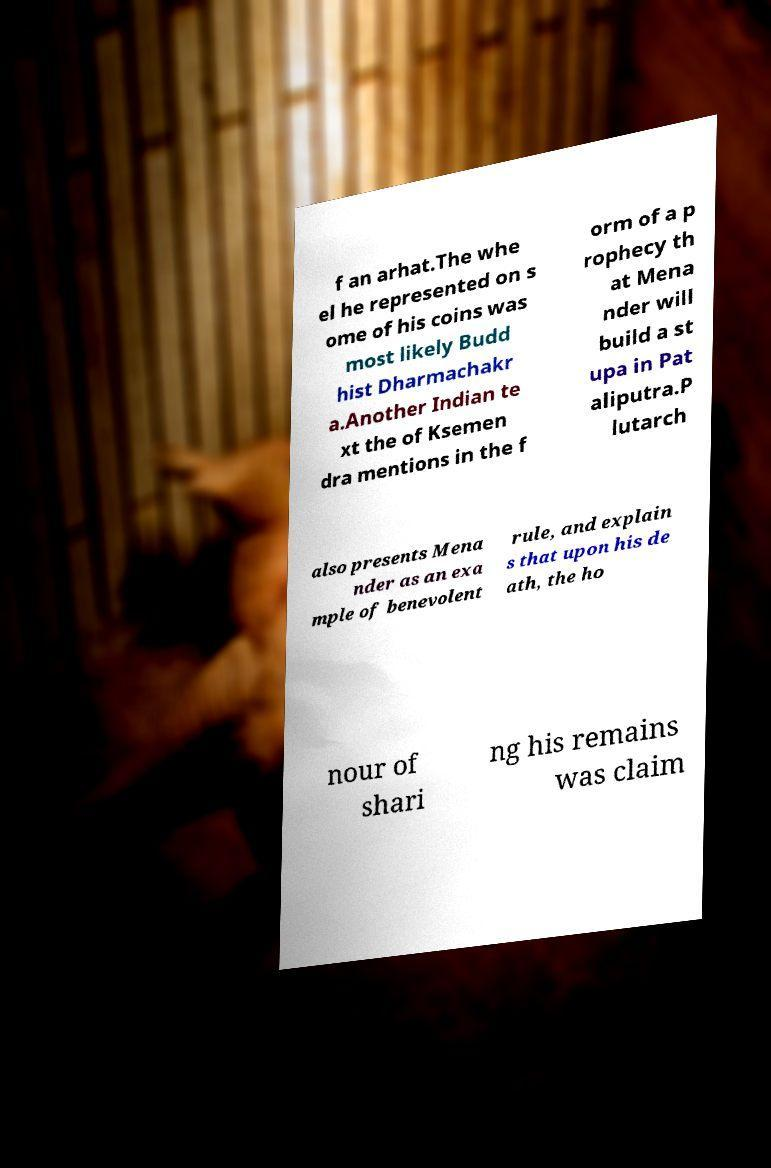For documentation purposes, I need the text within this image transcribed. Could you provide that? f an arhat.The whe el he represented on s ome of his coins was most likely Budd hist Dharmachakr a.Another Indian te xt the of Ksemen dra mentions in the f orm of a p rophecy th at Mena nder will build a st upa in Pat aliputra.P lutarch also presents Mena nder as an exa mple of benevolent rule, and explain s that upon his de ath, the ho nour of shari ng his remains was claim 